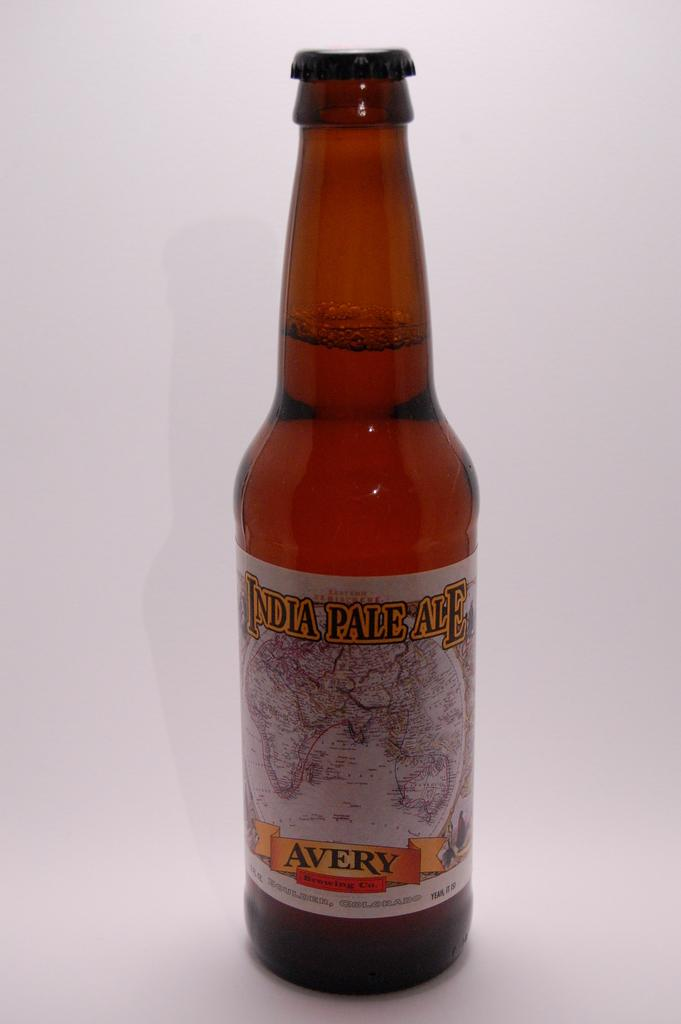Provide a one-sentence caption for the provided image. A bottle of India Pale Ale by the Avery Brewing Co. is shown. 